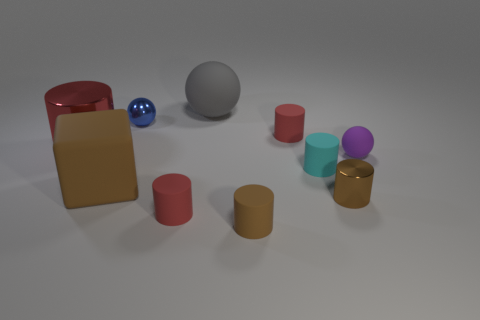How do the different colors of the objects contribute to the overall aesthetic of the image? The various colors of the objects in the image contribute to an overall pleasing and harmonious aesthetic by providing contrast and variety. The pops of red, blue, purple, and gold add visual interest to the composition, standing out against the neutral background and grey ball. 